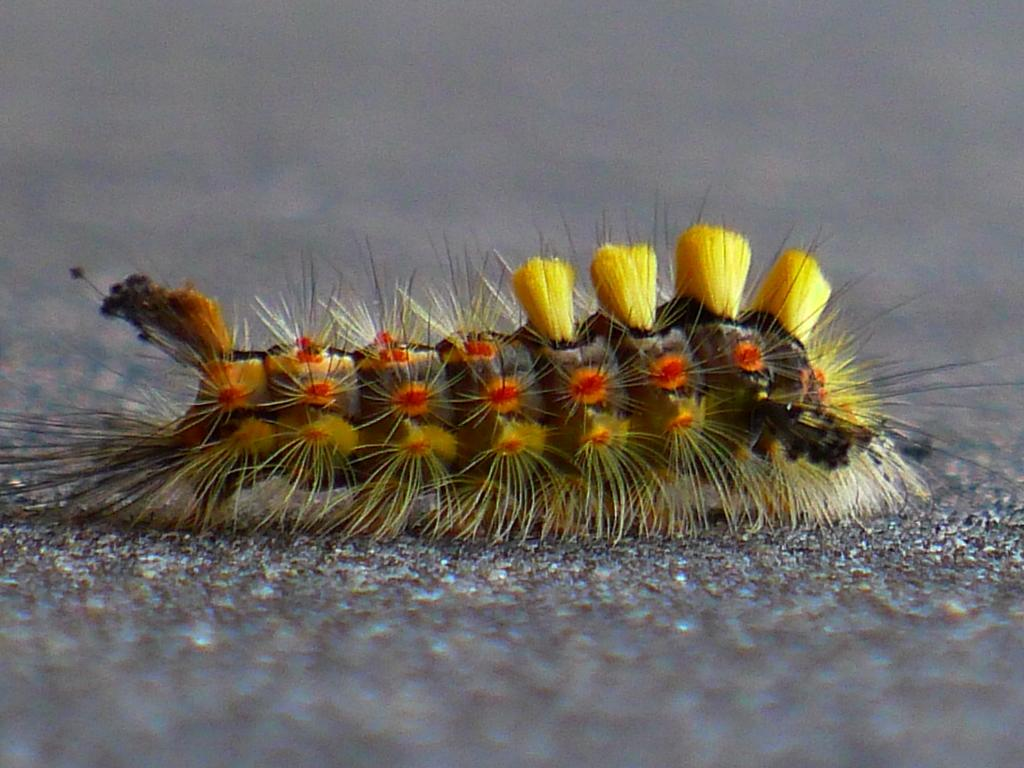What type of animal is in the image? There is an earthworm in the image. Where is the earthworm located in the image? The earthworm is on the ground. What type of minister is present in the image? There is no minister present in the image; it features an earthworm on the ground. What type of robin can be seen flying in the image? There is no robin present in the image; it features an earthworm on the ground. 